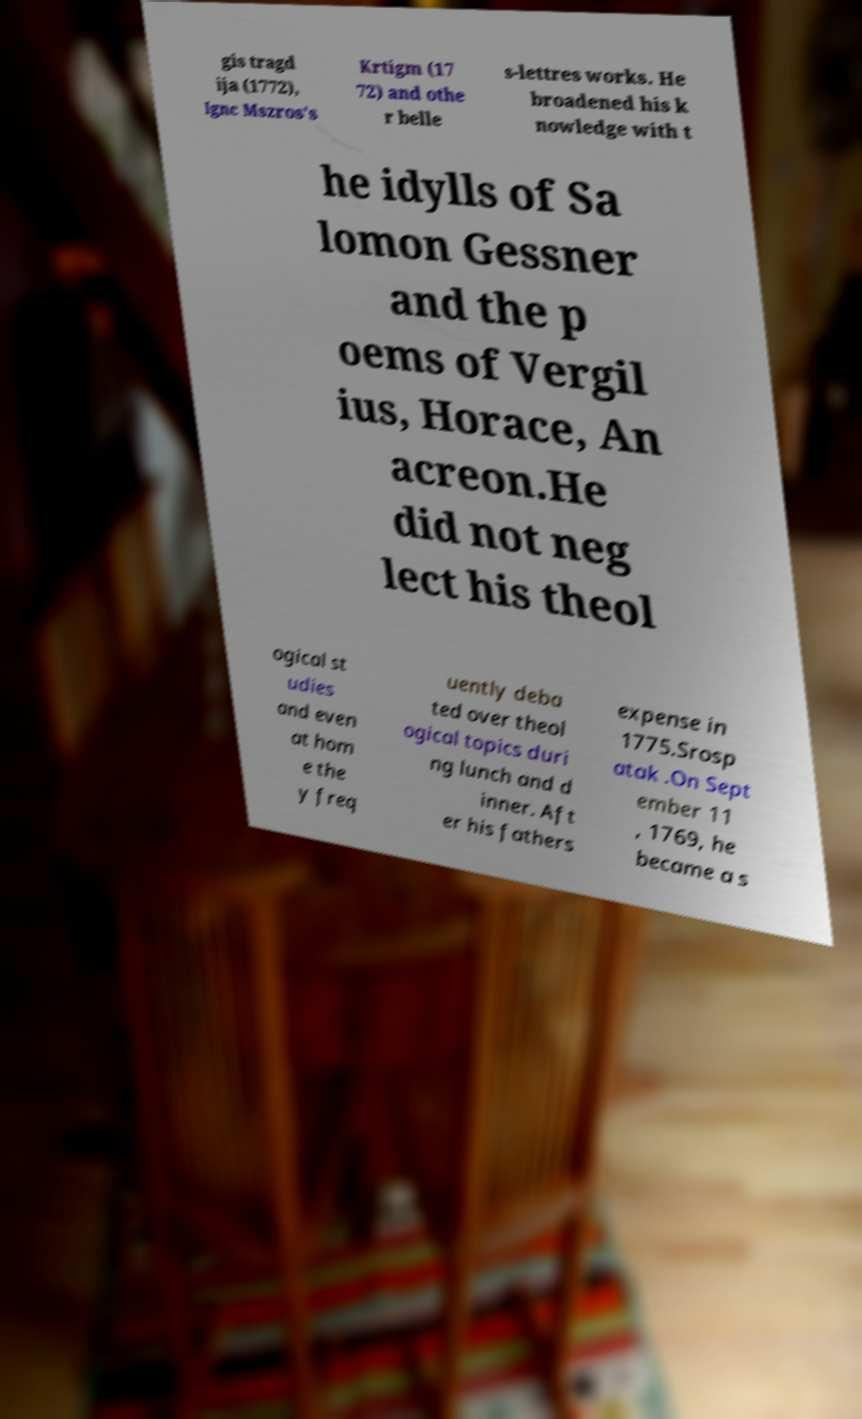Could you assist in decoding the text presented in this image and type it out clearly? gis tragd ija (1772), Ignc Mszros's Krtigm (17 72) and othe r belle s-lettres works. He broadened his k nowledge with t he idylls of Sa lomon Gessner and the p oems of Vergil ius, Horace, An acreon.He did not neg lect his theol ogical st udies and even at hom e the y freq uently deba ted over theol ogical topics duri ng lunch and d inner. Aft er his fathers expense in 1775.Srosp atak .On Sept ember 11 , 1769, he became a s 